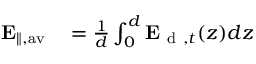Convert formula to latex. <formula><loc_0><loc_0><loc_500><loc_500>\begin{array} { r l } { E _ { \| , a v } } & = \frac { 1 } { d } \int _ { 0 } ^ { d } E _ { d , t } ( z ) d z } \end{array}</formula> 